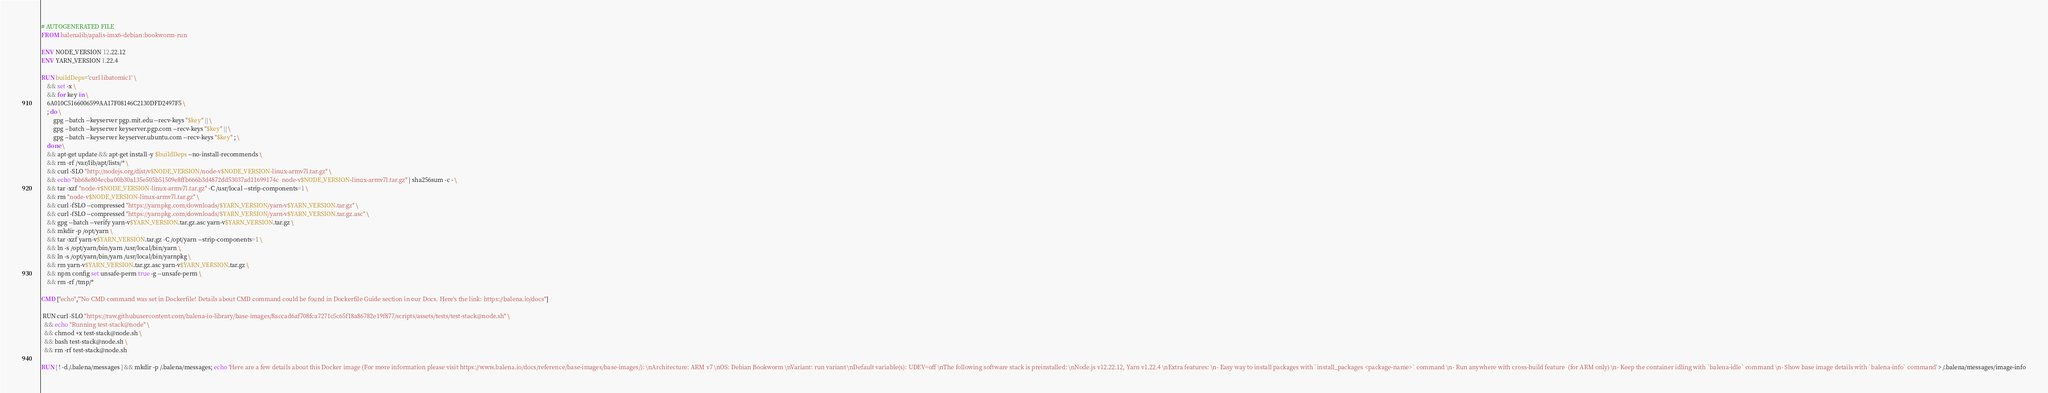Convert code to text. <code><loc_0><loc_0><loc_500><loc_500><_Dockerfile_># AUTOGENERATED FILE
FROM balenalib/apalis-imx6-debian:bookworm-run

ENV NODE_VERSION 12.22.12
ENV YARN_VERSION 1.22.4

RUN buildDeps='curl libatomic1' \
	&& set -x \
	&& for key in \
	6A010C5166006599AA17F08146C2130DFD2497F5 \
	; do \
		gpg --batch --keyserver pgp.mit.edu --recv-keys "$key" || \
		gpg --batch --keyserver keyserver.pgp.com --recv-keys "$key" || \
		gpg --batch --keyserver keyserver.ubuntu.com --recv-keys "$key" ; \
	done \
	&& apt-get update && apt-get install -y $buildDeps --no-install-recommends \
	&& rm -rf /var/lib/apt/lists/* \
	&& curl -SLO "http://nodejs.org/dist/v$NODE_VERSION/node-v$NODE_VERSION-linux-armv7l.tar.gz" \
	&& echo "bb68e804ecba00b30a135e505b51509e8ffb666b3d4872dd53037ad11699174c  node-v$NODE_VERSION-linux-armv7l.tar.gz" | sha256sum -c - \
	&& tar -xzf "node-v$NODE_VERSION-linux-armv7l.tar.gz" -C /usr/local --strip-components=1 \
	&& rm "node-v$NODE_VERSION-linux-armv7l.tar.gz" \
	&& curl -fSLO --compressed "https://yarnpkg.com/downloads/$YARN_VERSION/yarn-v$YARN_VERSION.tar.gz" \
	&& curl -fSLO --compressed "https://yarnpkg.com/downloads/$YARN_VERSION/yarn-v$YARN_VERSION.tar.gz.asc" \
	&& gpg --batch --verify yarn-v$YARN_VERSION.tar.gz.asc yarn-v$YARN_VERSION.tar.gz \
	&& mkdir -p /opt/yarn \
	&& tar -xzf yarn-v$YARN_VERSION.tar.gz -C /opt/yarn --strip-components=1 \
	&& ln -s /opt/yarn/bin/yarn /usr/local/bin/yarn \
	&& ln -s /opt/yarn/bin/yarn /usr/local/bin/yarnpkg \
	&& rm yarn-v$YARN_VERSION.tar.gz.asc yarn-v$YARN_VERSION.tar.gz \
	&& npm config set unsafe-perm true -g --unsafe-perm \
	&& rm -rf /tmp/*

CMD ["echo","'No CMD command was set in Dockerfile! Details about CMD command could be found in Dockerfile Guide section in our Docs. Here's the link: https://balena.io/docs"]

 RUN curl -SLO "https://raw.githubusercontent.com/balena-io-library/base-images/8accad6af708fca7271c5c65f18a86782e19f877/scripts/assets/tests/test-stack@node.sh" \
  && echo "Running test-stack@node" \
  && chmod +x test-stack@node.sh \
  && bash test-stack@node.sh \
  && rm -rf test-stack@node.sh 

RUN [ ! -d /.balena/messages ] && mkdir -p /.balena/messages; echo 'Here are a few details about this Docker image (For more information please visit https://www.balena.io/docs/reference/base-images/base-images/): \nArchitecture: ARM v7 \nOS: Debian Bookworm \nVariant: run variant \nDefault variable(s): UDEV=off \nThe following software stack is preinstalled: \nNode.js v12.22.12, Yarn v1.22.4 \nExtra features: \n- Easy way to install packages with `install_packages <package-name>` command \n- Run anywhere with cross-build feature  (for ARM only) \n- Keep the container idling with `balena-idle` command \n- Show base image details with `balena-info` command' > /.balena/messages/image-info</code> 